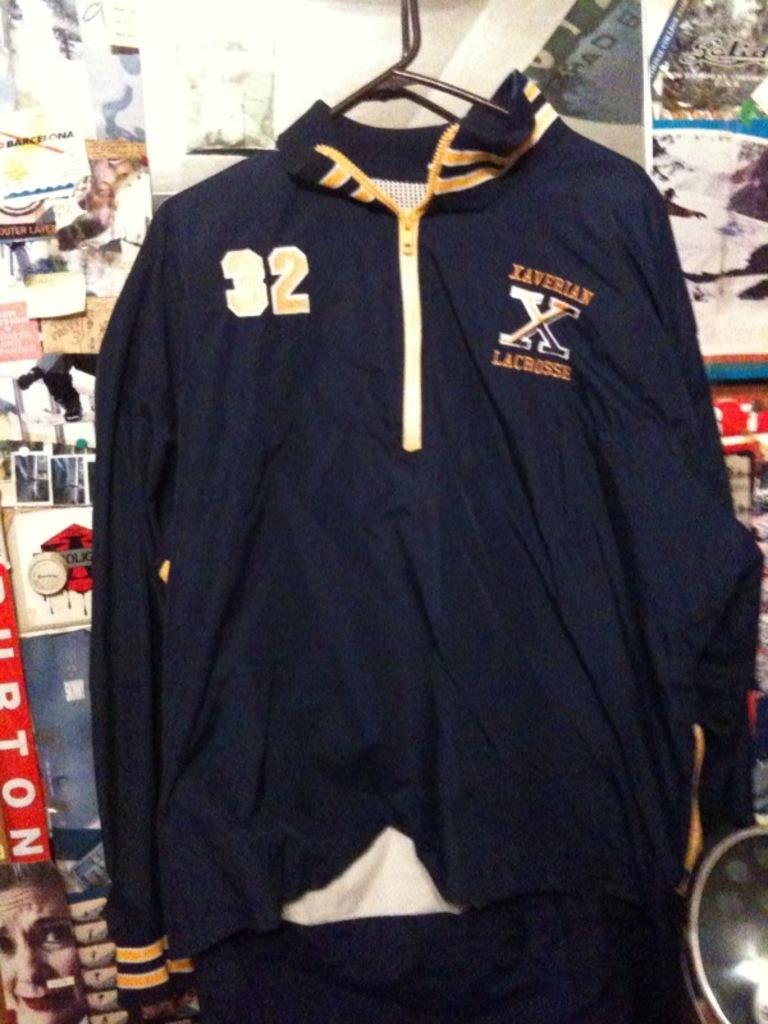What type of clothing item is visible in the image? There is a jacket in the image. What can be seen on the wall in the background of the image? There are papers pasted on the wall in the background of the image. How does the jacket care for the plants in the image? The jacket does not care for any plants in the image; it is a clothing item and not a living organism. 